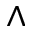<formula> <loc_0><loc_0><loc_500><loc_500>\wedge</formula> 